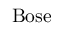Convert formula to latex. <formula><loc_0><loc_0><loc_500><loc_500>B o s e</formula> 